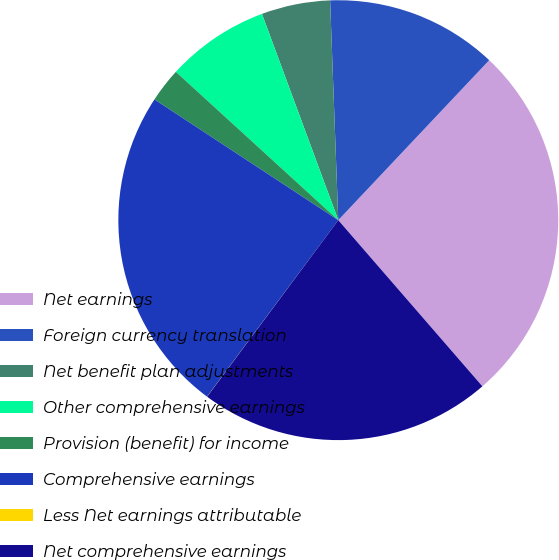Convert chart to OTSL. <chart><loc_0><loc_0><loc_500><loc_500><pie_chart><fcel>Net earnings<fcel>Foreign currency translation<fcel>Net benefit plan adjustments<fcel>Other comprehensive earnings<fcel>Provision (benefit) for income<fcel>Comprehensive earnings<fcel>Less Net earnings attributable<fcel>Net comprehensive earnings<nl><fcel>26.59%<fcel>12.63%<fcel>5.05%<fcel>7.58%<fcel>2.53%<fcel>24.07%<fcel>0.01%<fcel>21.54%<nl></chart> 